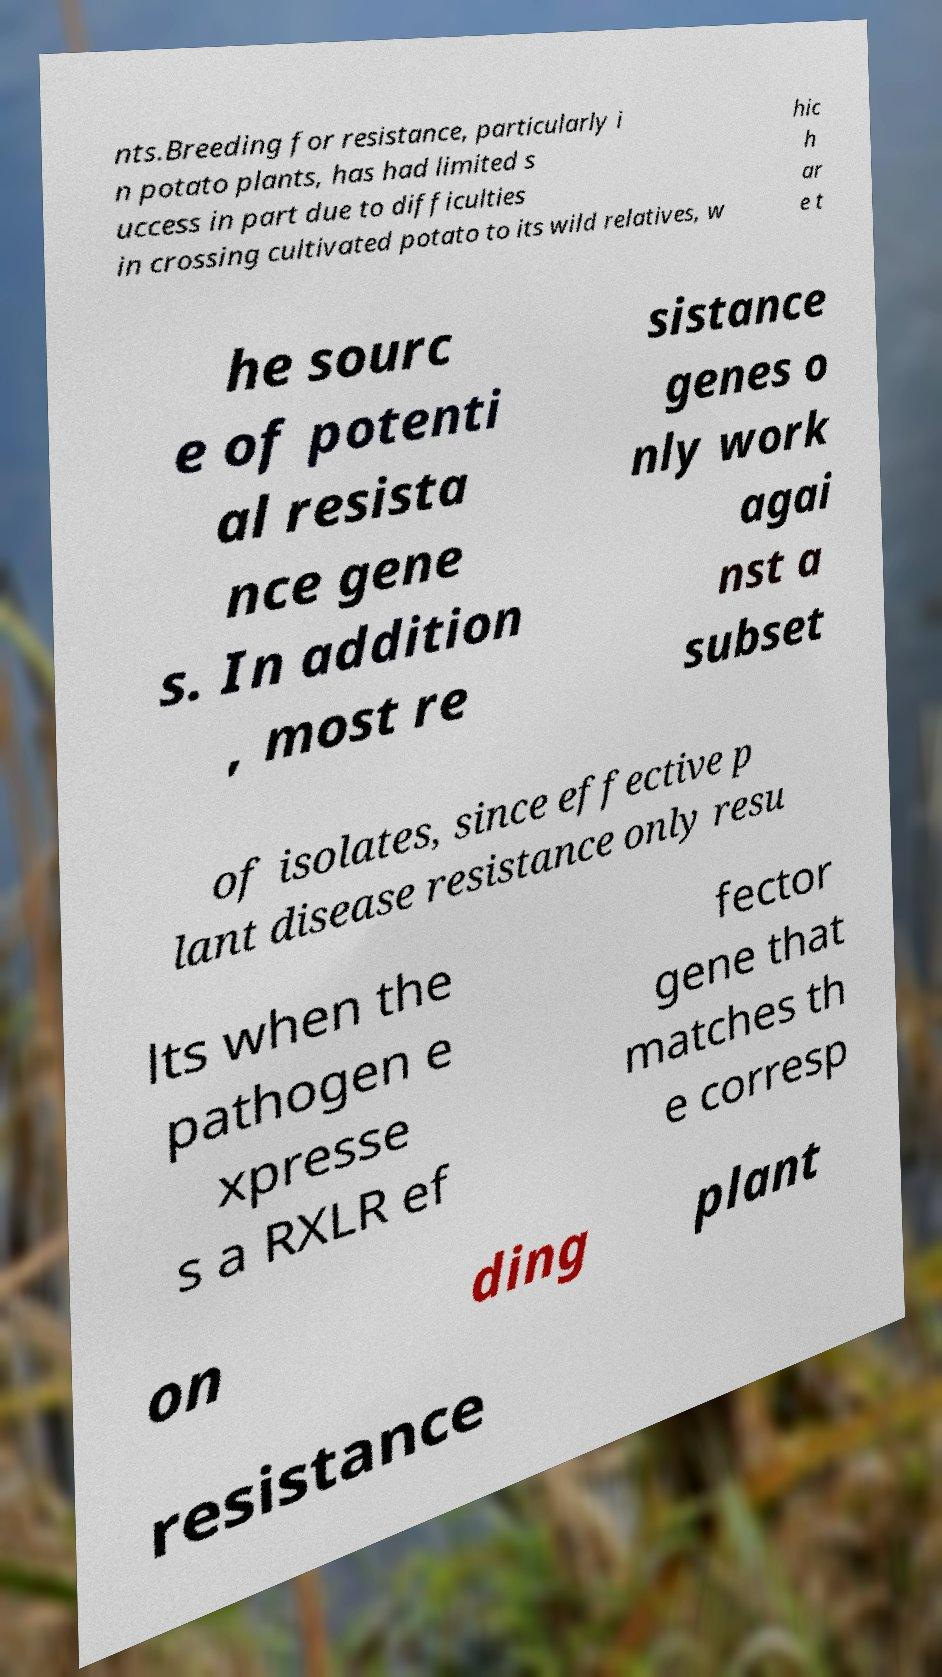What messages or text are displayed in this image? I need them in a readable, typed format. nts.Breeding for resistance, particularly i n potato plants, has had limited s uccess in part due to difficulties in crossing cultivated potato to its wild relatives, w hic h ar e t he sourc e of potenti al resista nce gene s. In addition , most re sistance genes o nly work agai nst a subset of isolates, since effective p lant disease resistance only resu lts when the pathogen e xpresse s a RXLR ef fector gene that matches th e corresp on ding plant resistance 